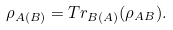Convert formula to latex. <formula><loc_0><loc_0><loc_500><loc_500>\rho _ { A ( B ) } = T r _ { B ( A ) } ( \rho _ { A B } ) .</formula> 